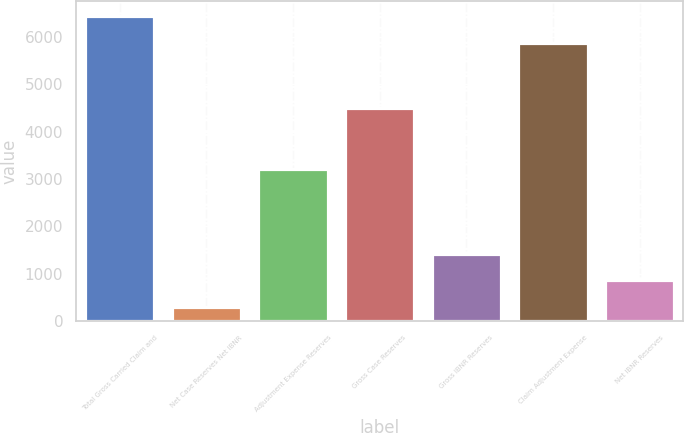Convert chart to OTSL. <chart><loc_0><loc_0><loc_500><loc_500><bar_chart><fcel>Total Gross Carried Claim and<fcel>Net Case Reserves Net IBNR<fcel>Adjustment Expense Reserves<fcel>Gross Case Reserves<fcel>Gross IBNR Reserves<fcel>Claim Adjustment Expense<fcel>Net IBNR Reserves<nl><fcel>6431.8<fcel>294<fcel>3213<fcel>4494<fcel>1429.6<fcel>5864<fcel>861.8<nl></chart> 